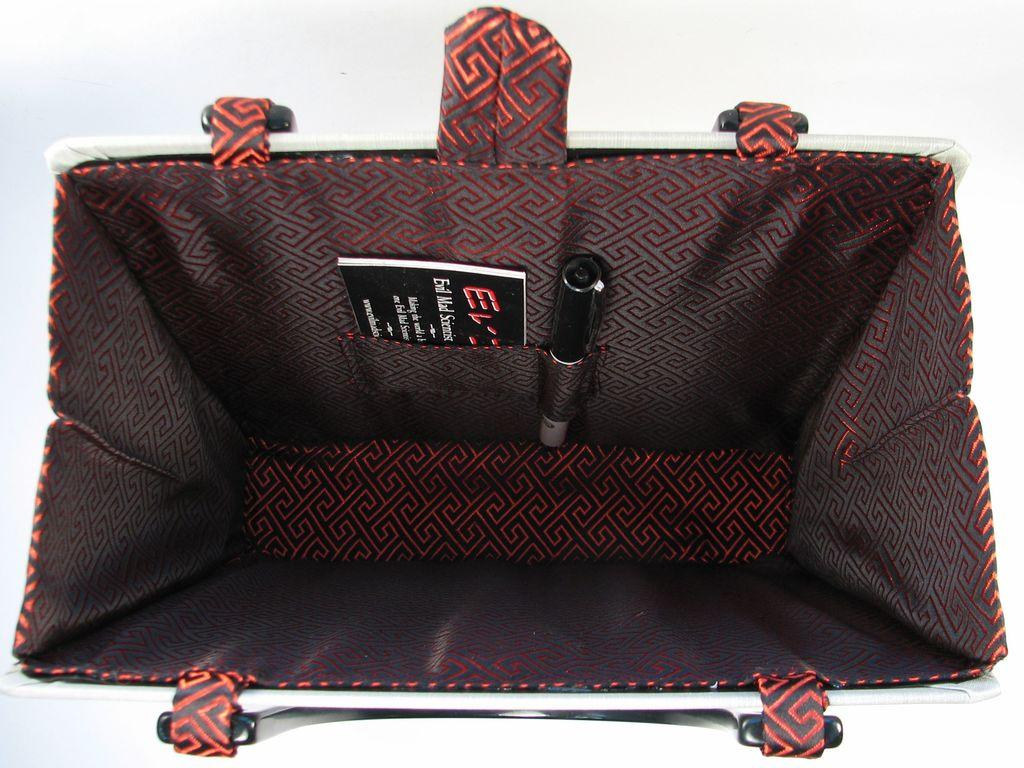What object is visible in the image? There is a bag in the image. What items can be found inside the bag? Inside the bag, there is a book and a pen. What is the color of the bag's attachment? The bag has a black color attachment. What type of humor can be found inside the bag? There is no humor present inside the bag; it contains a book and a pen. 